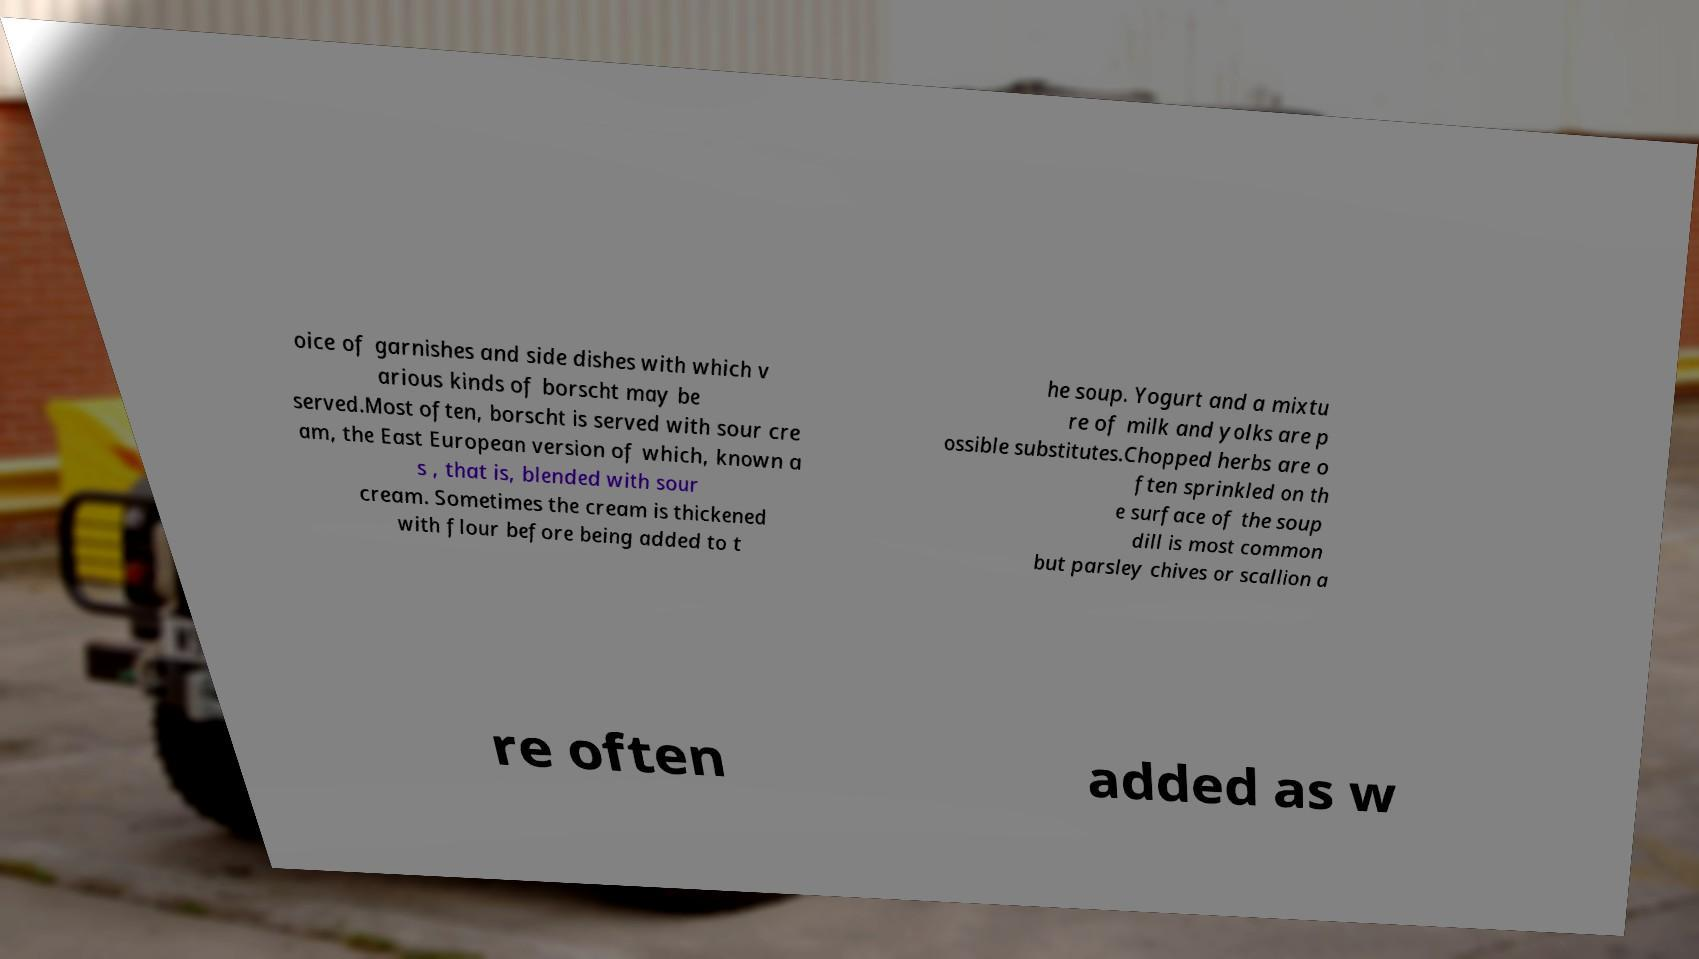Please identify and transcribe the text found in this image. oice of garnishes and side dishes with which v arious kinds of borscht may be served.Most often, borscht is served with sour cre am, the East European version of which, known a s , that is, blended with sour cream. Sometimes the cream is thickened with flour before being added to t he soup. Yogurt and a mixtu re of milk and yolks are p ossible substitutes.Chopped herbs are o ften sprinkled on th e surface of the soup dill is most common but parsley chives or scallion a re often added as w 